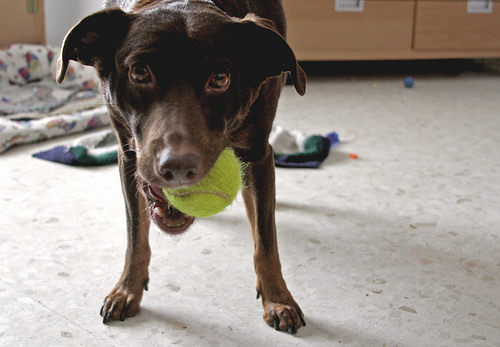<image>
Can you confirm if the ball is on the dog? No. The ball is not positioned on the dog. They may be near each other, but the ball is not supported by or resting on top of the dog. Is there a ball in the dog? Yes. The ball is contained within or inside the dog, showing a containment relationship. 